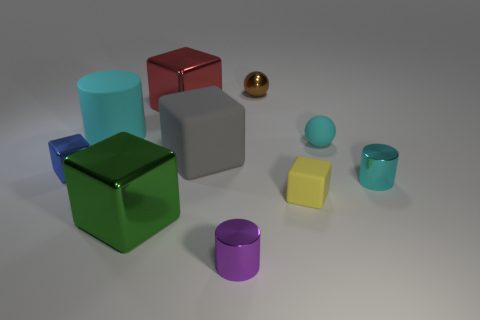Subtract all big shiny blocks. How many blocks are left? 3 Subtract all blue cubes. How many cubes are left? 4 Subtract all gray cubes. Subtract all blue cylinders. How many cubes are left? 4 Subtract all cylinders. How many objects are left? 7 Add 3 big metal cubes. How many big metal cubes exist? 5 Subtract 0 blue cylinders. How many objects are left? 10 Subtract all tiny yellow objects. Subtract all large gray things. How many objects are left? 8 Add 7 spheres. How many spheres are left? 9 